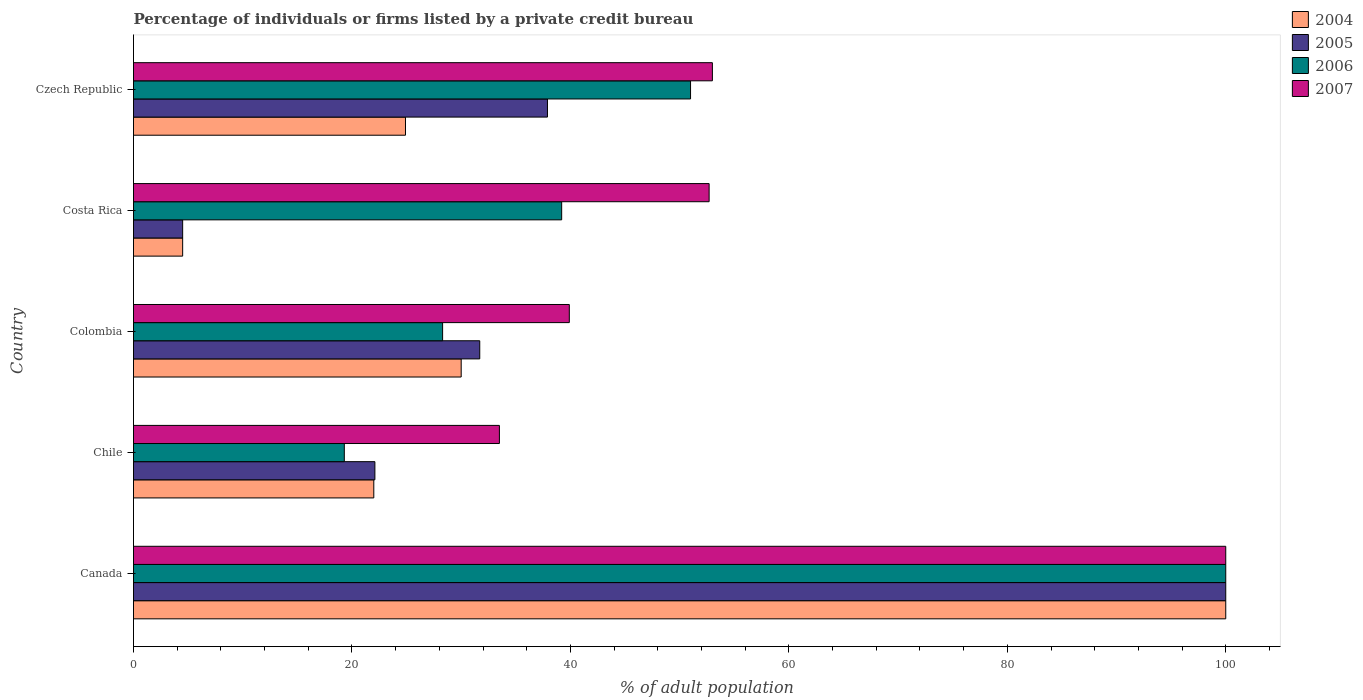Are the number of bars per tick equal to the number of legend labels?
Give a very brief answer. Yes. How many bars are there on the 4th tick from the top?
Provide a short and direct response. 4. How many bars are there on the 1st tick from the bottom?
Ensure brevity in your answer.  4. What is the label of the 5th group of bars from the top?
Your answer should be compact. Canada. In how many cases, is the number of bars for a given country not equal to the number of legend labels?
Your answer should be very brief. 0. Across all countries, what is the maximum percentage of population listed by a private credit bureau in 2004?
Your response must be concise. 100. Across all countries, what is the minimum percentage of population listed by a private credit bureau in 2007?
Your response must be concise. 33.5. In which country was the percentage of population listed by a private credit bureau in 2007 maximum?
Offer a terse response. Canada. In which country was the percentage of population listed by a private credit bureau in 2007 minimum?
Offer a very short reply. Chile. What is the total percentage of population listed by a private credit bureau in 2004 in the graph?
Your response must be concise. 181.4. What is the difference between the percentage of population listed by a private credit bureau in 2005 in Costa Rica and that in Czech Republic?
Your response must be concise. -33.4. What is the difference between the percentage of population listed by a private credit bureau in 2007 in Czech Republic and the percentage of population listed by a private credit bureau in 2005 in Canada?
Your response must be concise. -47. What is the average percentage of population listed by a private credit bureau in 2004 per country?
Your response must be concise. 36.28. What is the difference between the percentage of population listed by a private credit bureau in 2007 and percentage of population listed by a private credit bureau in 2005 in Colombia?
Give a very brief answer. 8.2. What is the ratio of the percentage of population listed by a private credit bureau in 2005 in Chile to that in Czech Republic?
Your response must be concise. 0.58. Is the difference between the percentage of population listed by a private credit bureau in 2007 in Colombia and Costa Rica greater than the difference between the percentage of population listed by a private credit bureau in 2005 in Colombia and Costa Rica?
Give a very brief answer. No. What is the difference between the highest and the second highest percentage of population listed by a private credit bureau in 2005?
Give a very brief answer. 62.1. What is the difference between the highest and the lowest percentage of population listed by a private credit bureau in 2006?
Provide a succinct answer. 80.7. Is the sum of the percentage of population listed by a private credit bureau in 2007 in Canada and Czech Republic greater than the maximum percentage of population listed by a private credit bureau in 2006 across all countries?
Ensure brevity in your answer.  Yes. How many bars are there?
Provide a succinct answer. 20. Are all the bars in the graph horizontal?
Make the answer very short. Yes. How many countries are there in the graph?
Your response must be concise. 5. Are the values on the major ticks of X-axis written in scientific E-notation?
Ensure brevity in your answer.  No. How are the legend labels stacked?
Offer a very short reply. Vertical. What is the title of the graph?
Provide a succinct answer. Percentage of individuals or firms listed by a private credit bureau. Does "1968" appear as one of the legend labels in the graph?
Offer a very short reply. No. What is the label or title of the X-axis?
Provide a succinct answer. % of adult population. What is the label or title of the Y-axis?
Make the answer very short. Country. What is the % of adult population of 2004 in Canada?
Offer a terse response. 100. What is the % of adult population in 2005 in Canada?
Give a very brief answer. 100. What is the % of adult population of 2007 in Canada?
Your response must be concise. 100. What is the % of adult population in 2004 in Chile?
Offer a terse response. 22. What is the % of adult population of 2005 in Chile?
Offer a very short reply. 22.1. What is the % of adult population in 2006 in Chile?
Provide a short and direct response. 19.3. What is the % of adult population of 2007 in Chile?
Offer a terse response. 33.5. What is the % of adult population in 2004 in Colombia?
Keep it short and to the point. 30. What is the % of adult population of 2005 in Colombia?
Provide a succinct answer. 31.7. What is the % of adult population in 2006 in Colombia?
Give a very brief answer. 28.3. What is the % of adult population in 2007 in Colombia?
Make the answer very short. 39.9. What is the % of adult population of 2005 in Costa Rica?
Your answer should be compact. 4.5. What is the % of adult population in 2006 in Costa Rica?
Make the answer very short. 39.2. What is the % of adult population of 2007 in Costa Rica?
Your answer should be very brief. 52.7. What is the % of adult population of 2004 in Czech Republic?
Offer a terse response. 24.9. What is the % of adult population in 2005 in Czech Republic?
Your answer should be compact. 37.9. What is the % of adult population of 2006 in Czech Republic?
Your answer should be compact. 51. What is the % of adult population in 2007 in Czech Republic?
Your response must be concise. 53. Across all countries, what is the maximum % of adult population of 2005?
Give a very brief answer. 100. Across all countries, what is the maximum % of adult population in 2006?
Your answer should be compact. 100. Across all countries, what is the maximum % of adult population of 2007?
Your answer should be very brief. 100. Across all countries, what is the minimum % of adult population in 2005?
Give a very brief answer. 4.5. Across all countries, what is the minimum % of adult population in 2006?
Give a very brief answer. 19.3. Across all countries, what is the minimum % of adult population in 2007?
Offer a terse response. 33.5. What is the total % of adult population of 2004 in the graph?
Keep it short and to the point. 181.4. What is the total % of adult population in 2005 in the graph?
Your answer should be very brief. 196.2. What is the total % of adult population in 2006 in the graph?
Ensure brevity in your answer.  237.8. What is the total % of adult population of 2007 in the graph?
Your answer should be very brief. 279.1. What is the difference between the % of adult population in 2005 in Canada and that in Chile?
Provide a succinct answer. 77.9. What is the difference between the % of adult population in 2006 in Canada and that in Chile?
Offer a terse response. 80.7. What is the difference between the % of adult population of 2007 in Canada and that in Chile?
Keep it short and to the point. 66.5. What is the difference between the % of adult population in 2004 in Canada and that in Colombia?
Keep it short and to the point. 70. What is the difference between the % of adult population of 2005 in Canada and that in Colombia?
Keep it short and to the point. 68.3. What is the difference between the % of adult population of 2006 in Canada and that in Colombia?
Provide a short and direct response. 71.7. What is the difference between the % of adult population in 2007 in Canada and that in Colombia?
Your answer should be very brief. 60.1. What is the difference between the % of adult population of 2004 in Canada and that in Costa Rica?
Your answer should be compact. 95.5. What is the difference between the % of adult population in 2005 in Canada and that in Costa Rica?
Your answer should be very brief. 95.5. What is the difference between the % of adult population of 2006 in Canada and that in Costa Rica?
Your response must be concise. 60.8. What is the difference between the % of adult population in 2007 in Canada and that in Costa Rica?
Offer a very short reply. 47.3. What is the difference between the % of adult population in 2004 in Canada and that in Czech Republic?
Make the answer very short. 75.1. What is the difference between the % of adult population in 2005 in Canada and that in Czech Republic?
Offer a terse response. 62.1. What is the difference between the % of adult population in 2006 in Canada and that in Czech Republic?
Provide a short and direct response. 49. What is the difference between the % of adult population of 2004 in Chile and that in Colombia?
Keep it short and to the point. -8. What is the difference between the % of adult population in 2007 in Chile and that in Colombia?
Provide a succinct answer. -6.4. What is the difference between the % of adult population of 2004 in Chile and that in Costa Rica?
Make the answer very short. 17.5. What is the difference between the % of adult population in 2005 in Chile and that in Costa Rica?
Provide a succinct answer. 17.6. What is the difference between the % of adult population of 2006 in Chile and that in Costa Rica?
Provide a short and direct response. -19.9. What is the difference between the % of adult population of 2007 in Chile and that in Costa Rica?
Give a very brief answer. -19.2. What is the difference between the % of adult population of 2005 in Chile and that in Czech Republic?
Offer a very short reply. -15.8. What is the difference between the % of adult population of 2006 in Chile and that in Czech Republic?
Your response must be concise. -31.7. What is the difference between the % of adult population in 2007 in Chile and that in Czech Republic?
Offer a terse response. -19.5. What is the difference between the % of adult population of 2005 in Colombia and that in Costa Rica?
Give a very brief answer. 27.2. What is the difference between the % of adult population in 2006 in Colombia and that in Costa Rica?
Offer a very short reply. -10.9. What is the difference between the % of adult population of 2005 in Colombia and that in Czech Republic?
Your answer should be very brief. -6.2. What is the difference between the % of adult population of 2006 in Colombia and that in Czech Republic?
Your response must be concise. -22.7. What is the difference between the % of adult population of 2007 in Colombia and that in Czech Republic?
Offer a terse response. -13.1. What is the difference between the % of adult population of 2004 in Costa Rica and that in Czech Republic?
Give a very brief answer. -20.4. What is the difference between the % of adult population in 2005 in Costa Rica and that in Czech Republic?
Ensure brevity in your answer.  -33.4. What is the difference between the % of adult population of 2006 in Costa Rica and that in Czech Republic?
Give a very brief answer. -11.8. What is the difference between the % of adult population of 2004 in Canada and the % of adult population of 2005 in Chile?
Make the answer very short. 77.9. What is the difference between the % of adult population in 2004 in Canada and the % of adult population in 2006 in Chile?
Your response must be concise. 80.7. What is the difference between the % of adult population in 2004 in Canada and the % of adult population in 2007 in Chile?
Your answer should be compact. 66.5. What is the difference between the % of adult population in 2005 in Canada and the % of adult population in 2006 in Chile?
Your answer should be compact. 80.7. What is the difference between the % of adult population in 2005 in Canada and the % of adult population in 2007 in Chile?
Give a very brief answer. 66.5. What is the difference between the % of adult population of 2006 in Canada and the % of adult population of 2007 in Chile?
Provide a short and direct response. 66.5. What is the difference between the % of adult population of 2004 in Canada and the % of adult population of 2005 in Colombia?
Provide a short and direct response. 68.3. What is the difference between the % of adult population of 2004 in Canada and the % of adult population of 2006 in Colombia?
Your answer should be very brief. 71.7. What is the difference between the % of adult population of 2004 in Canada and the % of adult population of 2007 in Colombia?
Your answer should be very brief. 60.1. What is the difference between the % of adult population of 2005 in Canada and the % of adult population of 2006 in Colombia?
Your answer should be very brief. 71.7. What is the difference between the % of adult population in 2005 in Canada and the % of adult population in 2007 in Colombia?
Your answer should be compact. 60.1. What is the difference between the % of adult population in 2006 in Canada and the % of adult population in 2007 in Colombia?
Your answer should be very brief. 60.1. What is the difference between the % of adult population of 2004 in Canada and the % of adult population of 2005 in Costa Rica?
Make the answer very short. 95.5. What is the difference between the % of adult population in 2004 in Canada and the % of adult population in 2006 in Costa Rica?
Your answer should be very brief. 60.8. What is the difference between the % of adult population of 2004 in Canada and the % of adult population of 2007 in Costa Rica?
Your response must be concise. 47.3. What is the difference between the % of adult population in 2005 in Canada and the % of adult population in 2006 in Costa Rica?
Your answer should be very brief. 60.8. What is the difference between the % of adult population of 2005 in Canada and the % of adult population of 2007 in Costa Rica?
Keep it short and to the point. 47.3. What is the difference between the % of adult population in 2006 in Canada and the % of adult population in 2007 in Costa Rica?
Offer a terse response. 47.3. What is the difference between the % of adult population in 2004 in Canada and the % of adult population in 2005 in Czech Republic?
Keep it short and to the point. 62.1. What is the difference between the % of adult population in 2005 in Canada and the % of adult population in 2007 in Czech Republic?
Provide a succinct answer. 47. What is the difference between the % of adult population of 2006 in Canada and the % of adult population of 2007 in Czech Republic?
Your response must be concise. 47. What is the difference between the % of adult population in 2004 in Chile and the % of adult population in 2005 in Colombia?
Provide a short and direct response. -9.7. What is the difference between the % of adult population of 2004 in Chile and the % of adult population of 2007 in Colombia?
Provide a succinct answer. -17.9. What is the difference between the % of adult population of 2005 in Chile and the % of adult population of 2006 in Colombia?
Ensure brevity in your answer.  -6.2. What is the difference between the % of adult population in 2005 in Chile and the % of adult population in 2007 in Colombia?
Your answer should be compact. -17.8. What is the difference between the % of adult population of 2006 in Chile and the % of adult population of 2007 in Colombia?
Offer a terse response. -20.6. What is the difference between the % of adult population in 2004 in Chile and the % of adult population in 2005 in Costa Rica?
Your response must be concise. 17.5. What is the difference between the % of adult population of 2004 in Chile and the % of adult population of 2006 in Costa Rica?
Provide a short and direct response. -17.2. What is the difference between the % of adult population of 2004 in Chile and the % of adult population of 2007 in Costa Rica?
Make the answer very short. -30.7. What is the difference between the % of adult population of 2005 in Chile and the % of adult population of 2006 in Costa Rica?
Your answer should be very brief. -17.1. What is the difference between the % of adult population of 2005 in Chile and the % of adult population of 2007 in Costa Rica?
Your response must be concise. -30.6. What is the difference between the % of adult population of 2006 in Chile and the % of adult population of 2007 in Costa Rica?
Provide a short and direct response. -33.4. What is the difference between the % of adult population in 2004 in Chile and the % of adult population in 2005 in Czech Republic?
Your answer should be very brief. -15.9. What is the difference between the % of adult population of 2004 in Chile and the % of adult population of 2007 in Czech Republic?
Offer a terse response. -31. What is the difference between the % of adult population of 2005 in Chile and the % of adult population of 2006 in Czech Republic?
Make the answer very short. -28.9. What is the difference between the % of adult population of 2005 in Chile and the % of adult population of 2007 in Czech Republic?
Your response must be concise. -30.9. What is the difference between the % of adult population of 2006 in Chile and the % of adult population of 2007 in Czech Republic?
Make the answer very short. -33.7. What is the difference between the % of adult population of 2004 in Colombia and the % of adult population of 2006 in Costa Rica?
Offer a very short reply. -9.2. What is the difference between the % of adult population in 2004 in Colombia and the % of adult population in 2007 in Costa Rica?
Provide a succinct answer. -22.7. What is the difference between the % of adult population in 2005 in Colombia and the % of adult population in 2006 in Costa Rica?
Make the answer very short. -7.5. What is the difference between the % of adult population of 2005 in Colombia and the % of adult population of 2007 in Costa Rica?
Give a very brief answer. -21. What is the difference between the % of adult population in 2006 in Colombia and the % of adult population in 2007 in Costa Rica?
Provide a short and direct response. -24.4. What is the difference between the % of adult population of 2004 in Colombia and the % of adult population of 2006 in Czech Republic?
Give a very brief answer. -21. What is the difference between the % of adult population of 2004 in Colombia and the % of adult population of 2007 in Czech Republic?
Ensure brevity in your answer.  -23. What is the difference between the % of adult population in 2005 in Colombia and the % of adult population in 2006 in Czech Republic?
Make the answer very short. -19.3. What is the difference between the % of adult population in 2005 in Colombia and the % of adult population in 2007 in Czech Republic?
Offer a terse response. -21.3. What is the difference between the % of adult population of 2006 in Colombia and the % of adult population of 2007 in Czech Republic?
Ensure brevity in your answer.  -24.7. What is the difference between the % of adult population in 2004 in Costa Rica and the % of adult population in 2005 in Czech Republic?
Provide a succinct answer. -33.4. What is the difference between the % of adult population of 2004 in Costa Rica and the % of adult population of 2006 in Czech Republic?
Ensure brevity in your answer.  -46.5. What is the difference between the % of adult population of 2004 in Costa Rica and the % of adult population of 2007 in Czech Republic?
Give a very brief answer. -48.5. What is the difference between the % of adult population of 2005 in Costa Rica and the % of adult population of 2006 in Czech Republic?
Your response must be concise. -46.5. What is the difference between the % of adult population of 2005 in Costa Rica and the % of adult population of 2007 in Czech Republic?
Provide a short and direct response. -48.5. What is the average % of adult population in 2004 per country?
Your answer should be compact. 36.28. What is the average % of adult population of 2005 per country?
Offer a very short reply. 39.24. What is the average % of adult population in 2006 per country?
Provide a succinct answer. 47.56. What is the average % of adult population of 2007 per country?
Keep it short and to the point. 55.82. What is the difference between the % of adult population in 2004 and % of adult population in 2006 in Canada?
Your answer should be very brief. 0. What is the difference between the % of adult population of 2004 and % of adult population of 2007 in Canada?
Your response must be concise. 0. What is the difference between the % of adult population in 2005 and % of adult population in 2006 in Canada?
Make the answer very short. 0. What is the difference between the % of adult population of 2004 and % of adult population of 2007 in Chile?
Give a very brief answer. -11.5. What is the difference between the % of adult population in 2005 and % of adult population in 2006 in Chile?
Ensure brevity in your answer.  2.8. What is the difference between the % of adult population in 2005 and % of adult population in 2007 in Chile?
Keep it short and to the point. -11.4. What is the difference between the % of adult population of 2004 and % of adult population of 2005 in Colombia?
Give a very brief answer. -1.7. What is the difference between the % of adult population of 2004 and % of adult population of 2006 in Colombia?
Offer a very short reply. 1.7. What is the difference between the % of adult population of 2005 and % of adult population of 2007 in Colombia?
Provide a succinct answer. -8.2. What is the difference between the % of adult population of 2004 and % of adult population of 2005 in Costa Rica?
Keep it short and to the point. 0. What is the difference between the % of adult population in 2004 and % of adult population in 2006 in Costa Rica?
Offer a terse response. -34.7. What is the difference between the % of adult population of 2004 and % of adult population of 2007 in Costa Rica?
Provide a short and direct response. -48.2. What is the difference between the % of adult population of 2005 and % of adult population of 2006 in Costa Rica?
Make the answer very short. -34.7. What is the difference between the % of adult population in 2005 and % of adult population in 2007 in Costa Rica?
Your answer should be very brief. -48.2. What is the difference between the % of adult population in 2004 and % of adult population in 2005 in Czech Republic?
Offer a terse response. -13. What is the difference between the % of adult population of 2004 and % of adult population of 2006 in Czech Republic?
Your answer should be compact. -26.1. What is the difference between the % of adult population in 2004 and % of adult population in 2007 in Czech Republic?
Provide a short and direct response. -28.1. What is the difference between the % of adult population of 2005 and % of adult population of 2006 in Czech Republic?
Provide a succinct answer. -13.1. What is the difference between the % of adult population in 2005 and % of adult population in 2007 in Czech Republic?
Your answer should be very brief. -15.1. What is the ratio of the % of adult population of 2004 in Canada to that in Chile?
Your answer should be very brief. 4.55. What is the ratio of the % of adult population of 2005 in Canada to that in Chile?
Keep it short and to the point. 4.52. What is the ratio of the % of adult population of 2006 in Canada to that in Chile?
Give a very brief answer. 5.18. What is the ratio of the % of adult population in 2007 in Canada to that in Chile?
Ensure brevity in your answer.  2.99. What is the ratio of the % of adult population in 2004 in Canada to that in Colombia?
Provide a short and direct response. 3.33. What is the ratio of the % of adult population in 2005 in Canada to that in Colombia?
Keep it short and to the point. 3.15. What is the ratio of the % of adult population in 2006 in Canada to that in Colombia?
Ensure brevity in your answer.  3.53. What is the ratio of the % of adult population in 2007 in Canada to that in Colombia?
Provide a succinct answer. 2.51. What is the ratio of the % of adult population in 2004 in Canada to that in Costa Rica?
Your answer should be compact. 22.22. What is the ratio of the % of adult population of 2005 in Canada to that in Costa Rica?
Make the answer very short. 22.22. What is the ratio of the % of adult population of 2006 in Canada to that in Costa Rica?
Offer a very short reply. 2.55. What is the ratio of the % of adult population in 2007 in Canada to that in Costa Rica?
Make the answer very short. 1.9. What is the ratio of the % of adult population of 2004 in Canada to that in Czech Republic?
Your response must be concise. 4.02. What is the ratio of the % of adult population in 2005 in Canada to that in Czech Republic?
Give a very brief answer. 2.64. What is the ratio of the % of adult population of 2006 in Canada to that in Czech Republic?
Offer a very short reply. 1.96. What is the ratio of the % of adult population in 2007 in Canada to that in Czech Republic?
Your answer should be compact. 1.89. What is the ratio of the % of adult population in 2004 in Chile to that in Colombia?
Provide a succinct answer. 0.73. What is the ratio of the % of adult population of 2005 in Chile to that in Colombia?
Offer a very short reply. 0.7. What is the ratio of the % of adult population of 2006 in Chile to that in Colombia?
Ensure brevity in your answer.  0.68. What is the ratio of the % of adult population of 2007 in Chile to that in Colombia?
Provide a short and direct response. 0.84. What is the ratio of the % of adult population in 2004 in Chile to that in Costa Rica?
Offer a very short reply. 4.89. What is the ratio of the % of adult population of 2005 in Chile to that in Costa Rica?
Provide a succinct answer. 4.91. What is the ratio of the % of adult population of 2006 in Chile to that in Costa Rica?
Offer a terse response. 0.49. What is the ratio of the % of adult population in 2007 in Chile to that in Costa Rica?
Your answer should be very brief. 0.64. What is the ratio of the % of adult population of 2004 in Chile to that in Czech Republic?
Keep it short and to the point. 0.88. What is the ratio of the % of adult population of 2005 in Chile to that in Czech Republic?
Make the answer very short. 0.58. What is the ratio of the % of adult population in 2006 in Chile to that in Czech Republic?
Your answer should be very brief. 0.38. What is the ratio of the % of adult population in 2007 in Chile to that in Czech Republic?
Your answer should be very brief. 0.63. What is the ratio of the % of adult population of 2004 in Colombia to that in Costa Rica?
Offer a very short reply. 6.67. What is the ratio of the % of adult population in 2005 in Colombia to that in Costa Rica?
Offer a very short reply. 7.04. What is the ratio of the % of adult population in 2006 in Colombia to that in Costa Rica?
Your response must be concise. 0.72. What is the ratio of the % of adult population of 2007 in Colombia to that in Costa Rica?
Your response must be concise. 0.76. What is the ratio of the % of adult population in 2004 in Colombia to that in Czech Republic?
Offer a terse response. 1.2. What is the ratio of the % of adult population in 2005 in Colombia to that in Czech Republic?
Provide a short and direct response. 0.84. What is the ratio of the % of adult population of 2006 in Colombia to that in Czech Republic?
Ensure brevity in your answer.  0.55. What is the ratio of the % of adult population in 2007 in Colombia to that in Czech Republic?
Your answer should be very brief. 0.75. What is the ratio of the % of adult population in 2004 in Costa Rica to that in Czech Republic?
Provide a succinct answer. 0.18. What is the ratio of the % of adult population in 2005 in Costa Rica to that in Czech Republic?
Give a very brief answer. 0.12. What is the ratio of the % of adult population of 2006 in Costa Rica to that in Czech Republic?
Make the answer very short. 0.77. What is the difference between the highest and the second highest % of adult population in 2005?
Your answer should be compact. 62.1. What is the difference between the highest and the second highest % of adult population of 2006?
Offer a terse response. 49. What is the difference between the highest and the lowest % of adult population of 2004?
Make the answer very short. 95.5. What is the difference between the highest and the lowest % of adult population in 2005?
Give a very brief answer. 95.5. What is the difference between the highest and the lowest % of adult population in 2006?
Your answer should be very brief. 80.7. What is the difference between the highest and the lowest % of adult population in 2007?
Make the answer very short. 66.5. 